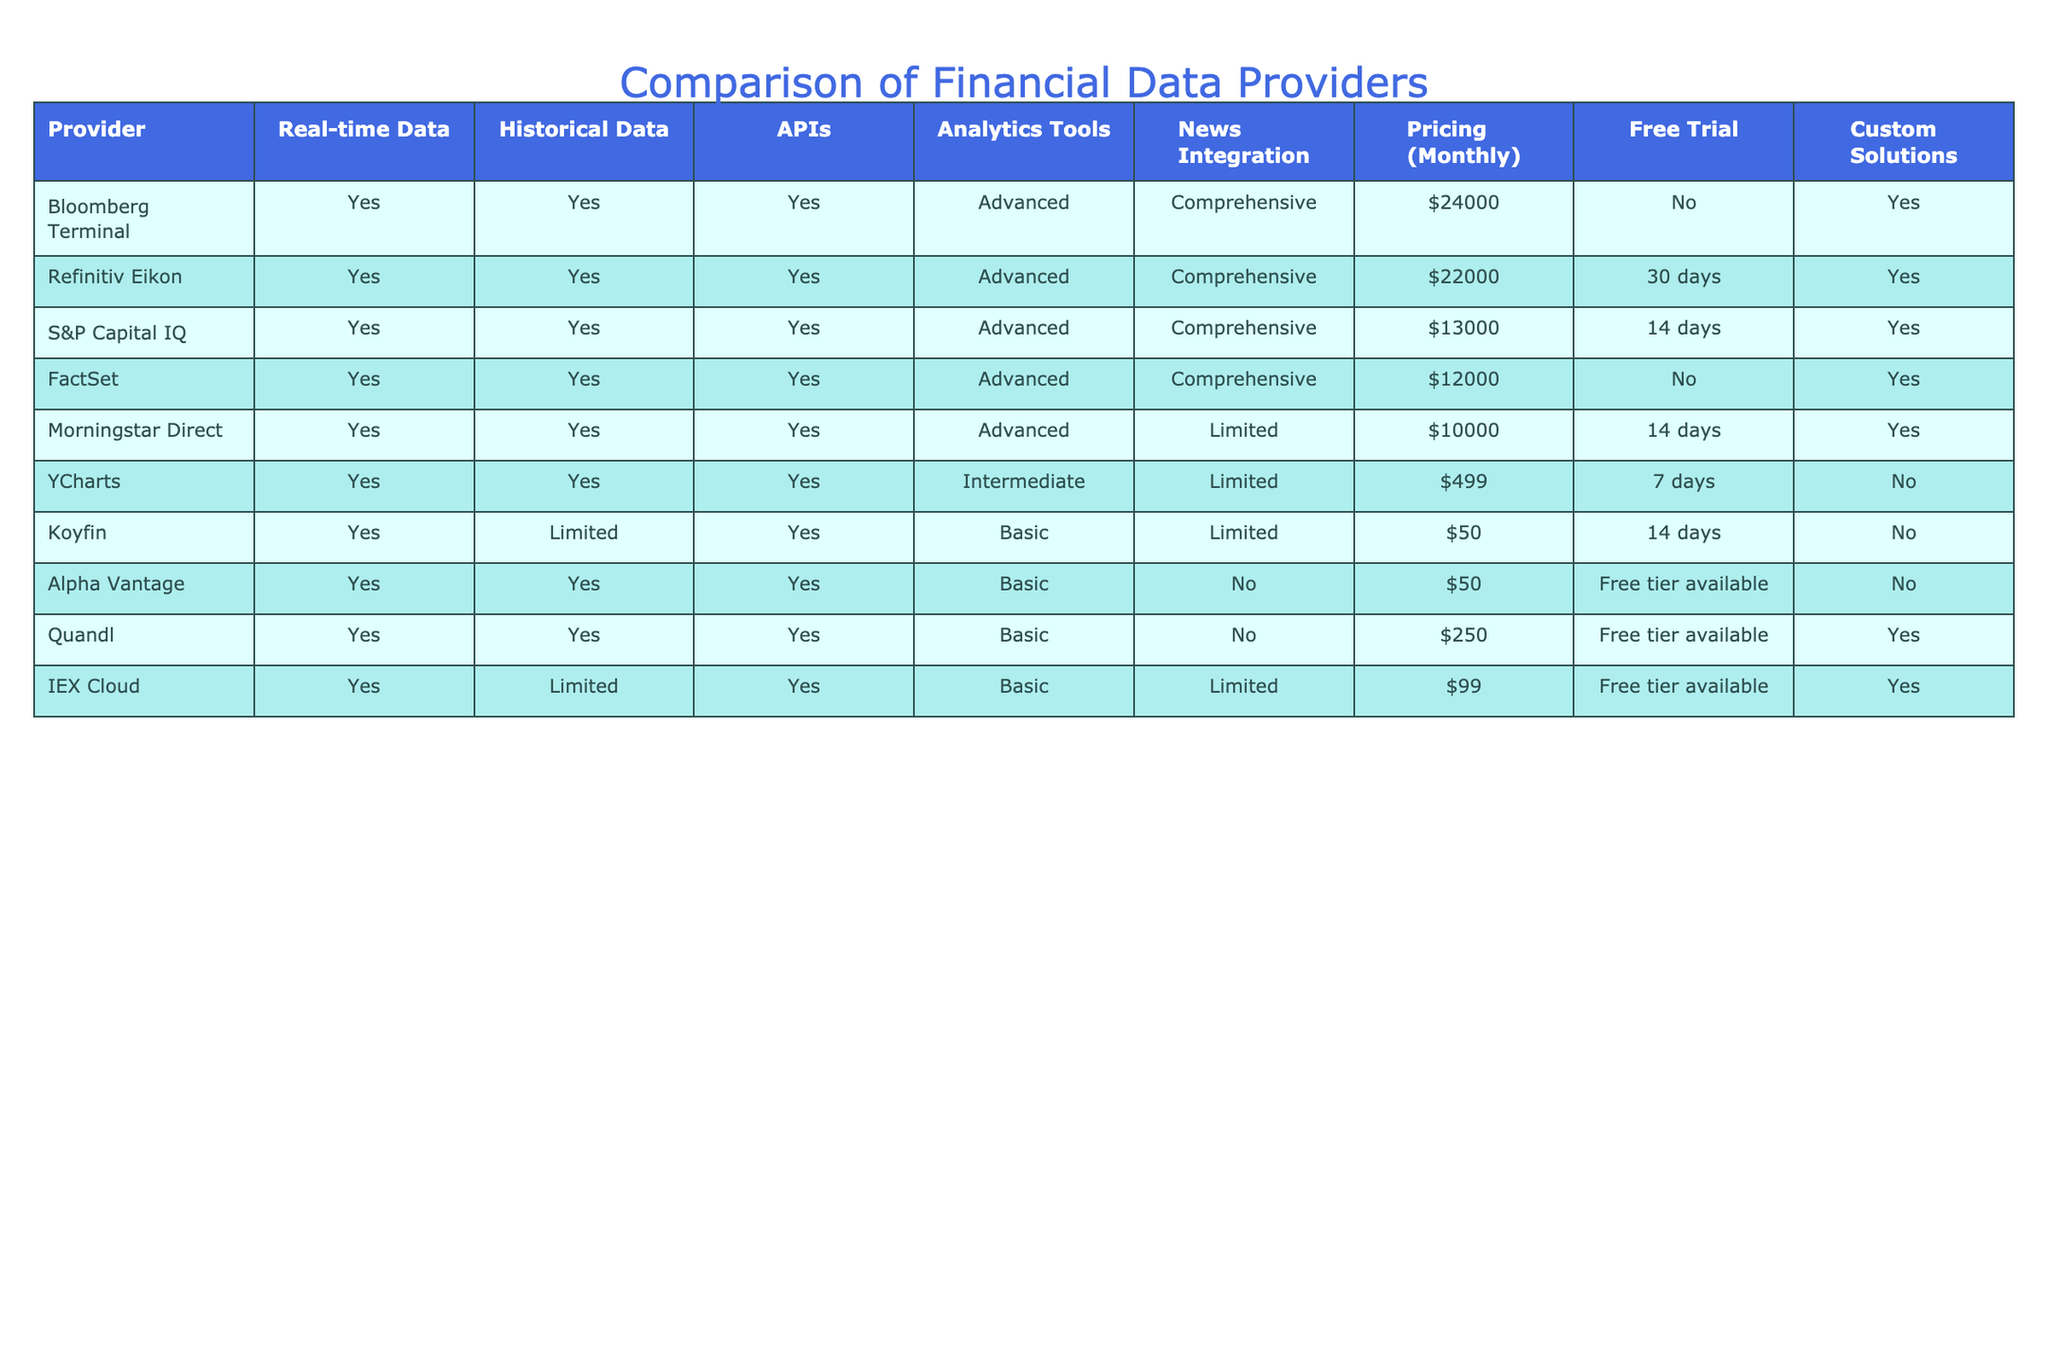What's the monthly pricing for the Bloomberg Terminal? The table lists the monthly price for the Bloomberg Terminal in the "Pricing (Monthly)" column, which shows $24000.
Answer: $24000 Which provider offers the least expensive monthly subscription? Upon examining the pricing in the "Pricing (Monthly)" column, I find that Koyfin has the lowest price at $50.
Answer: $50 Do all providers offer a free trial? By checking the "Free Trial" column, I see that some providers such as Bloomberg Terminal, FactSet, and YCharts do not offer a free trial, indicating that not all providers have this option.
Answer: No Is it true that Refinitiv Eikon has a comprehensive news integration feature? Looking at the "News Integration" column for Refinitiv Eikon, I can confirm that it is marked as "Comprehensive," thus making the statement true.
Answer: Yes What is the average monthly price of the top three most expensive providers? First, I identify the top three most expensive providers, which are Bloomberg Terminal ($24000), Refinitiv Eikon ($22000), and S&P Capital IQ ($13000). I then calculate the sum (24000 + 22000 + 13000) = 59000, and divide by 3 to find the average, 59000/3 ≈ 19667.
Answer: 19667 Which provider has the most advanced analytics tools and provides custom solutions? Observing the "Analytics Tools" and "Custom Solutions" columns, I find that Bloomberg Terminal, Refinitiv Eikon, S&P Capital IQ, FactSet, and Morningstar Direct have advanced analytics tools. Out of these, Bloomberg Terminal, Refinitiv Eikon, and S&P Capital IQ provide custom solutions. Hence, those three fit the criteria.
Answer: Bloomberg Terminal, Refinitiv Eikon, S&P Capital IQ How many providers offer both real-time data and historical data? From the "Real-time Data" and "Historical Data" columns, I see that all providers listed have "Yes" in both categories. There are a total of 10 providers, indicating that all of them provide both.
Answer: 10 Is the historical data feature available with YCharts? Referencing the "Historical Data" column, I can see that YCharts has it indicated as "Yes," confirming the availability of the historical data feature.
Answer: Yes Calculate the total monthly price for the top three providers with limited analytics tools. The three providers with limited analytics tools are Koyfin ($50), Alpha Vantage ($50), and IEX Cloud ($99). Adding these amounts (50 + 50 + 99) results in a total of $199.
Answer: $199 